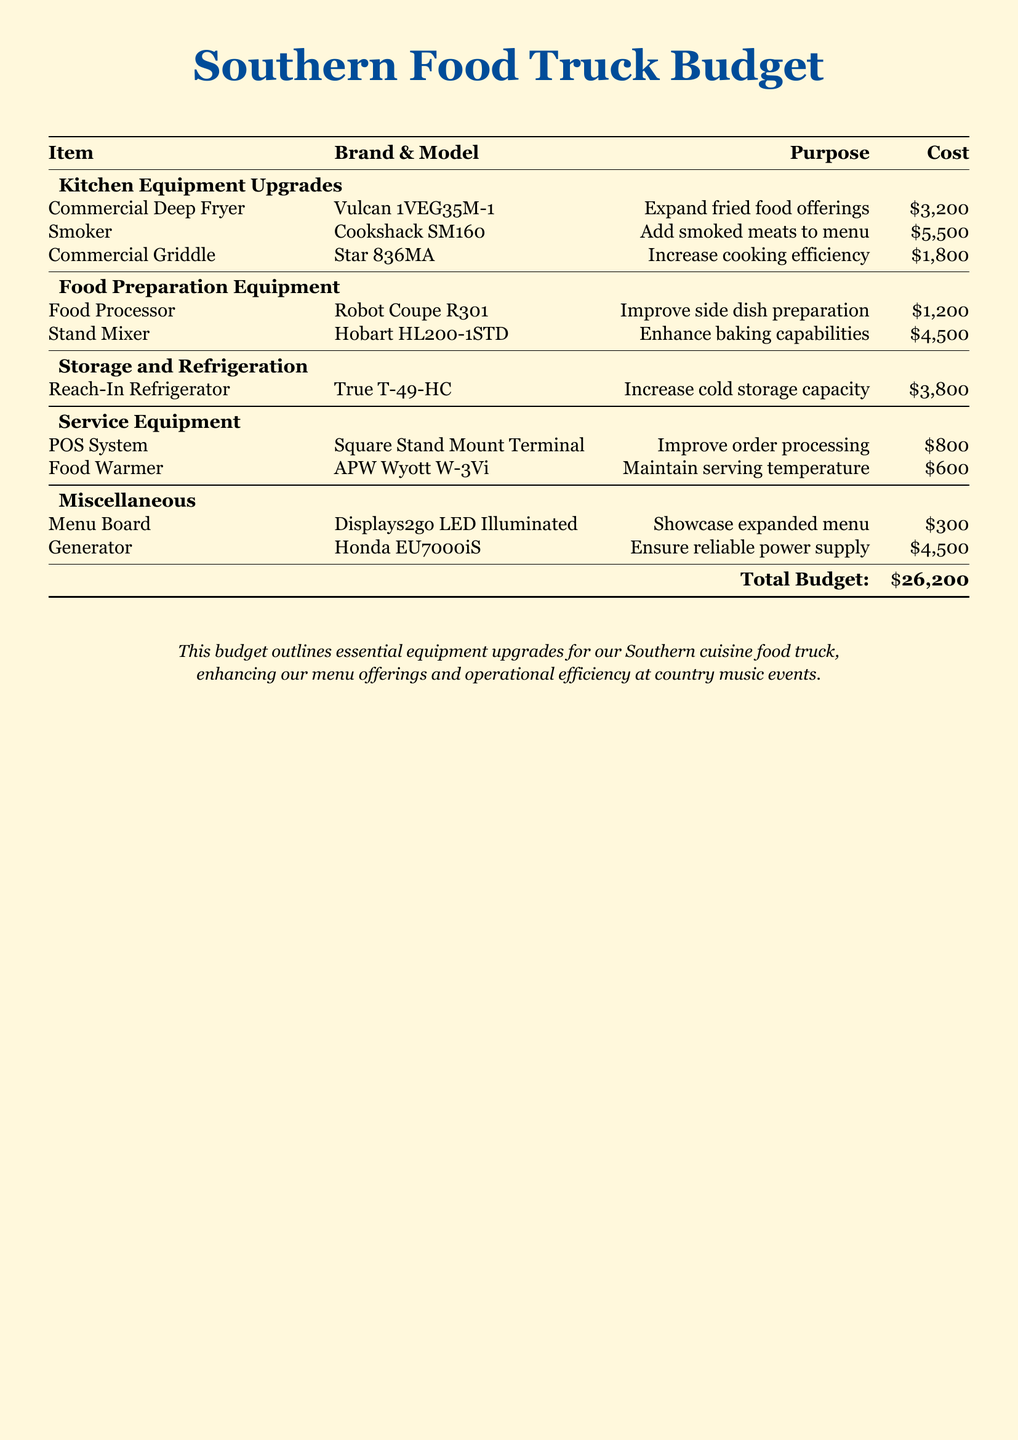what is the total budget? The total budget is stated at the bottom of the table and is the sum of all equipment costs.
Answer: $26,200 how much does the Commercial Deep Fryer cost? The cost for the Commercial Deep Fryer is listed in the Kitchen Equipment Upgrades section.
Answer: $3,200 which equipment is intended to add smoked meats to the menu? This information pertains to the specific equipment listed for enhancing menu offerings, found in the Kitchen Equipment Upgrades section.
Answer: Smoker what is the purpose of the POS System? The purpose of the POS System is outlined in the Service Equipment section and specifies its function in the food truck.
Answer: Improve order processing which item has the highest cost? This question requires comparing the costs of all items in the budget to determine the most expensive one.
Answer: Smoker how much does the Generator cost? The cost for the Generator is specified in the Miscellaneous section of the document.
Answer: $4,500 how many items are listed under Food Preparation Equipment? This requires counting the number of entries in the Food Preparation Equipment section of the budget.
Answer: 2 what is the purpose of the Food Warmer? The purpose of the Food Warmer is specified in the Service Equipment section, detailing its role in food service.
Answer: Maintain serving temperature what type of document is this? Understanding the nature of the document based on its content and layout reveals its purpose.
Answer: Budget 